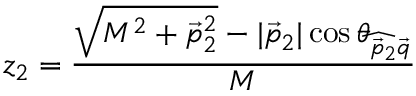<formula> <loc_0><loc_0><loc_500><loc_500>z _ { 2 } = \frac { \sqrt { M ^ { 2 } + \vec { p } _ { 2 } ^ { 2 } } - | \vec { p } _ { 2 } | \cos \theta _ { \widehat { \vec { p } _ { 2 } \vec { q } } } } { M }</formula> 